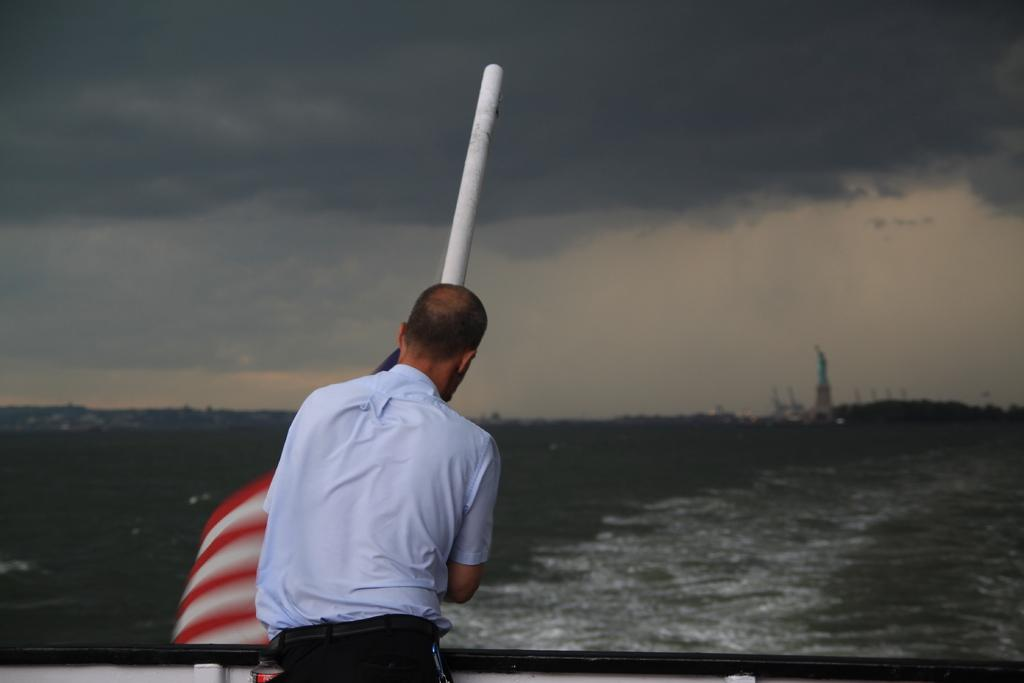What is the main subject of the image? There is a man standing in the image. What is the man wearing? The man is wearing a shirt and a pant. What can be seen in the background of the image? There is water, a white color pole, and the sky visible in the background of the image. What type of songs can be heard being sung by the man in the image? There is no indication in the image that the man is singing or that any songs are being played. 